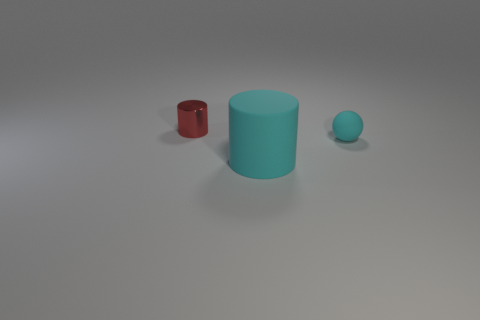Are there any other big cyan rubber things of the same shape as the large rubber object?
Provide a short and direct response. No. Are there fewer tiny yellow matte cylinders than cyan rubber spheres?
Offer a terse response. Yes. There is a object in front of the small cyan rubber sphere; is it the same size as the cylinder behind the tiny matte ball?
Make the answer very short. No. What number of things are small metal cylinders or large cyan matte things?
Offer a very short reply. 2. There is a cylinder behind the tiny rubber thing; what is its size?
Offer a very short reply. Small. What number of tiny matte spheres are to the right of the tiny object behind the small thing on the right side of the tiny shiny cylinder?
Provide a succinct answer. 1. Does the matte cylinder have the same color as the tiny cylinder?
Ensure brevity in your answer.  No. How many objects are both left of the tiny cyan ball and behind the cyan cylinder?
Make the answer very short. 1. The rubber object in front of the small cyan object has what shape?
Your answer should be compact. Cylinder. Are there fewer cyan spheres on the right side of the tiny cyan rubber thing than rubber objects that are right of the big matte cylinder?
Provide a short and direct response. Yes. 